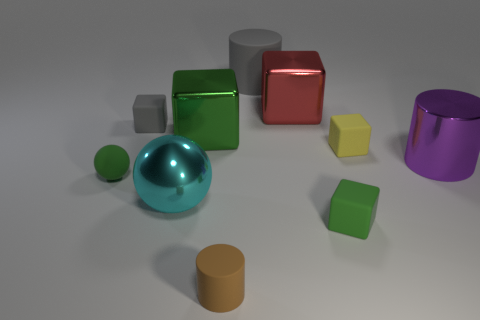Is there a gray rubber cube that is in front of the gray matte object left of the big rubber thing?
Keep it short and to the point. No. What number of cylinders are either big rubber objects or gray things?
Keep it short and to the point. 1. How big is the gray object that is to the right of the tiny object that is in front of the small green matte object in front of the green rubber ball?
Ensure brevity in your answer.  Large. There is a big gray rubber thing; are there any tiny brown things behind it?
Provide a succinct answer. No. How many objects are either metal cubes that are in front of the red metallic thing or balls?
Your response must be concise. 3. There is a cyan object that is made of the same material as the big green thing; what size is it?
Provide a succinct answer. Large. There is a purple cylinder; does it have the same size as the green cube that is behind the big cyan metal sphere?
Give a very brief answer. Yes. There is a rubber object that is both left of the big green cube and behind the tiny yellow object; what color is it?
Give a very brief answer. Gray. How many objects are big blocks behind the tiny gray rubber cube or metal objects in front of the big red shiny block?
Make the answer very short. 4. There is a large metal cube that is left of the rubber cylinder in front of the large metallic cube behind the gray cube; what is its color?
Offer a terse response. Green. 